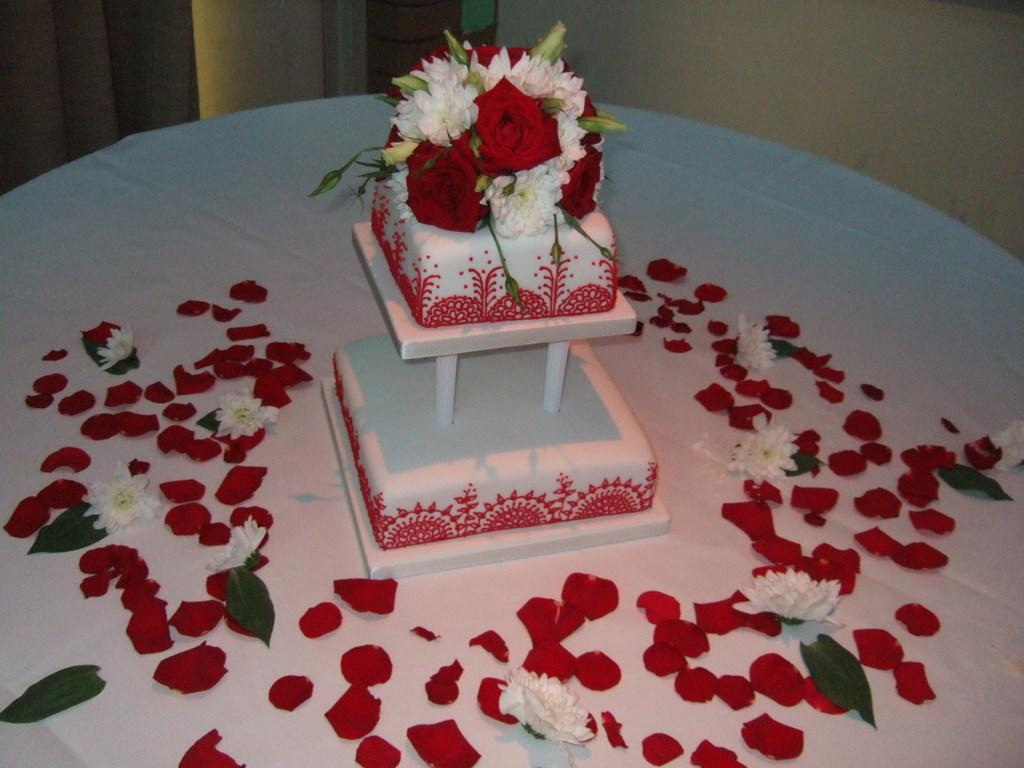What is the main subject of the image? There is a cake in the image. What is the cake placed on? The cake is on a white cloth. What decorative elements are present beside the cake? There are petals, flowers, and leaves beside the cake. What can be seen at the top of the image? There is a wall visible at the top of the image. How many friends are sitting on the beds in the image? There are no friends or beds present in the image; it features a cake on a white cloth with decorative elements beside it. 